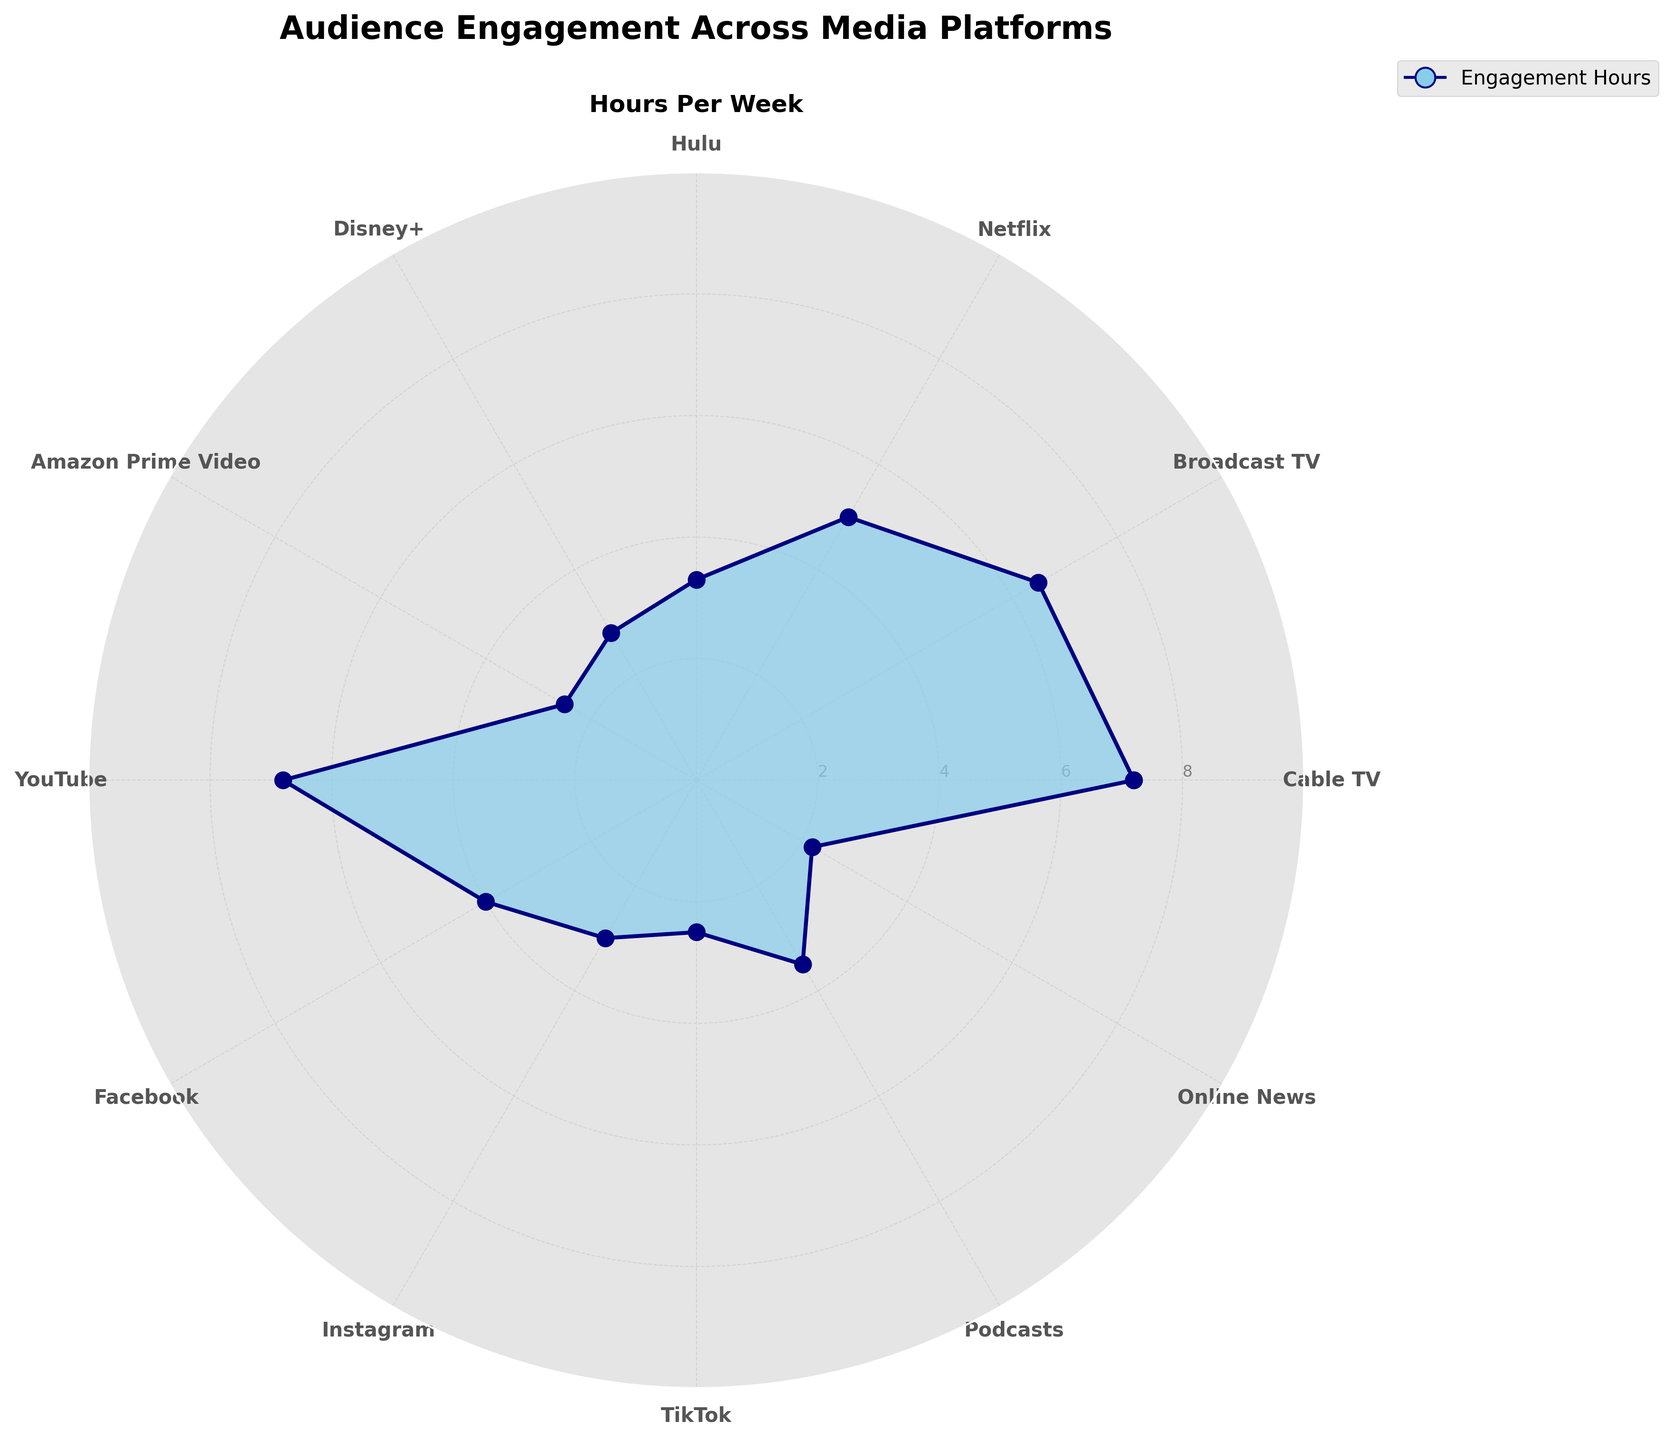Which media platform shows the highest audience engagement? Look at the peak of the filled area in the polar chart. The maximum value is at Cable TV with 7.2 hours per week.
Answer: Cable TV What is the title of the chart? Refer to the top of the chart where the title is displayed. It reads "Audience Engagement Across Media Platforms".
Answer: Audience Engagement Across Media Platforms How many hours per week do users spend on YouTube compared to Disney+? YouTube shows approximately 6.8 hours per week of engagement while Disney+ shows approximately 2.8 hours per week. Subtracting both gives (6.8 - 2.8) = 4 hours difference.
Answer: 4 hours What is the average engagement time across Amazon Prime, Hulu, and Disney+? Sum the hours per week for these platforms: 2.5 (Amazon Prime) + 3.3 (Hulu) + 2.8 (Disney+), which gives 8.6 hours. Divide by 3 to get the average: 8.6/3 ≈ 2.87 hours.
Answer: 2.87 hours How does engagement on Podcasts compare to Instagram? Podcasts show an engagement of approximately 3.5 hours per week while Instagram shows 3.0 hours per week. Podcasts have a higher engagement (3.5 > 3.0).
Answer: Podcasts Which platform has the closest engagement time to TikTok? TikTok has an engagement time of approximately 2.5 hours per week. The closest in time is Amazon Prime Video with the same 2.5 hours.
Answer: Amazon Prime Video What is the total engagement time for all the social media platforms combined (YouTube, Facebook, Instagram, TikTok)? Add the hours per week for these platforms: 6.8 (YouTube) + 4.0 (Facebook) + 3.0 (Instagram) + 2.5 (TikTok) = 16.3 hours per week.
Answer: 16.3 hours Between Cable TV and Broadcast TV, which one sees more engagement and by how much? Cable TV has approximately 7.2 hours while Broadcast TV has 6.5 hours. The difference is (7.2 - 6.5) = 0.7 hours.
Answer: Cable TV by 0.7 hours How many media platforms have more than 5 hours of engagement per week? By examining the radial ticks and filled area, platforms with more than 5 hours are Cable TV, Broadcast TV, and YouTube. Therefore, there are 3 platforms.
Answer: 3 platforms Is there a platform where engagement is under 3 hours per week? Platforms under this threshold are Disney+ (2.8), Amazon Prime Video (2.5), TikTok (2.5), and Online News (2.2).
Answer: Yes 